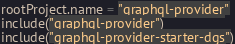Convert code to text. <code><loc_0><loc_0><loc_500><loc_500><_Kotlin_>rootProject.name = "graphql-provider"
include("graphql-provider")
include("graphql-provider-starter-dgs")
</code> 